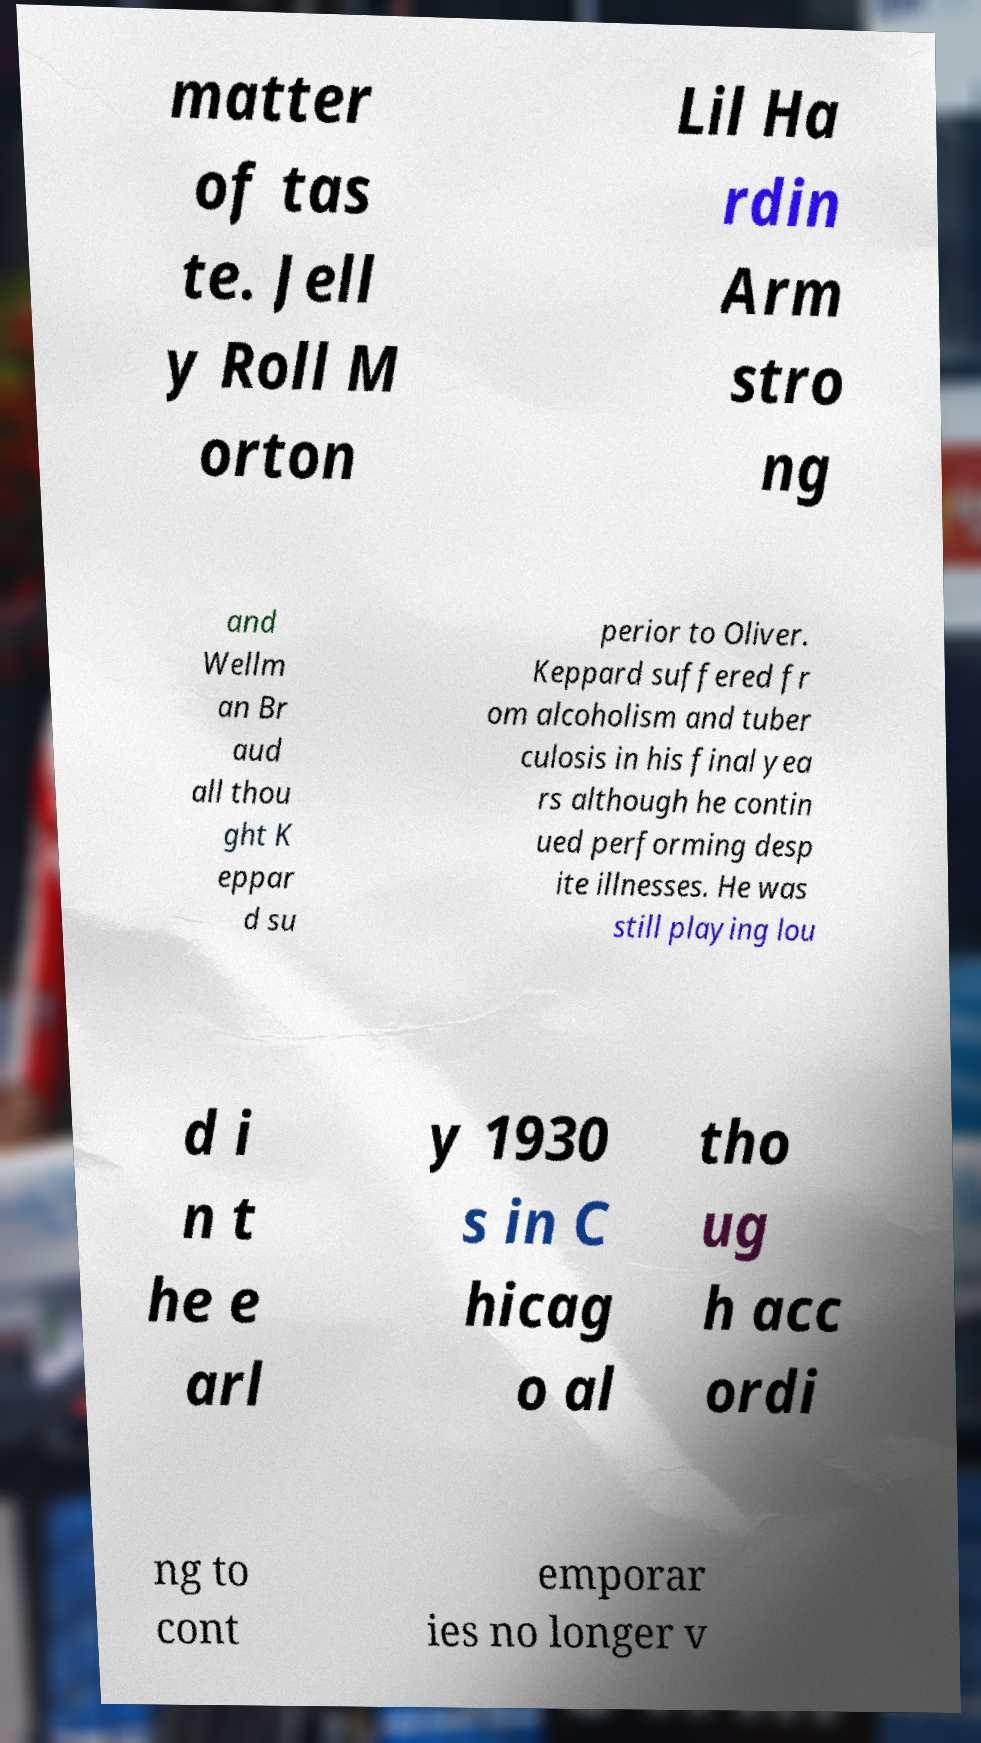Please read and relay the text visible in this image. What does it say? matter of tas te. Jell y Roll M orton Lil Ha rdin Arm stro ng and Wellm an Br aud all thou ght K eppar d su perior to Oliver. Keppard suffered fr om alcoholism and tuber culosis in his final yea rs although he contin ued performing desp ite illnesses. He was still playing lou d i n t he e arl y 1930 s in C hicag o al tho ug h acc ordi ng to cont emporar ies no longer v 